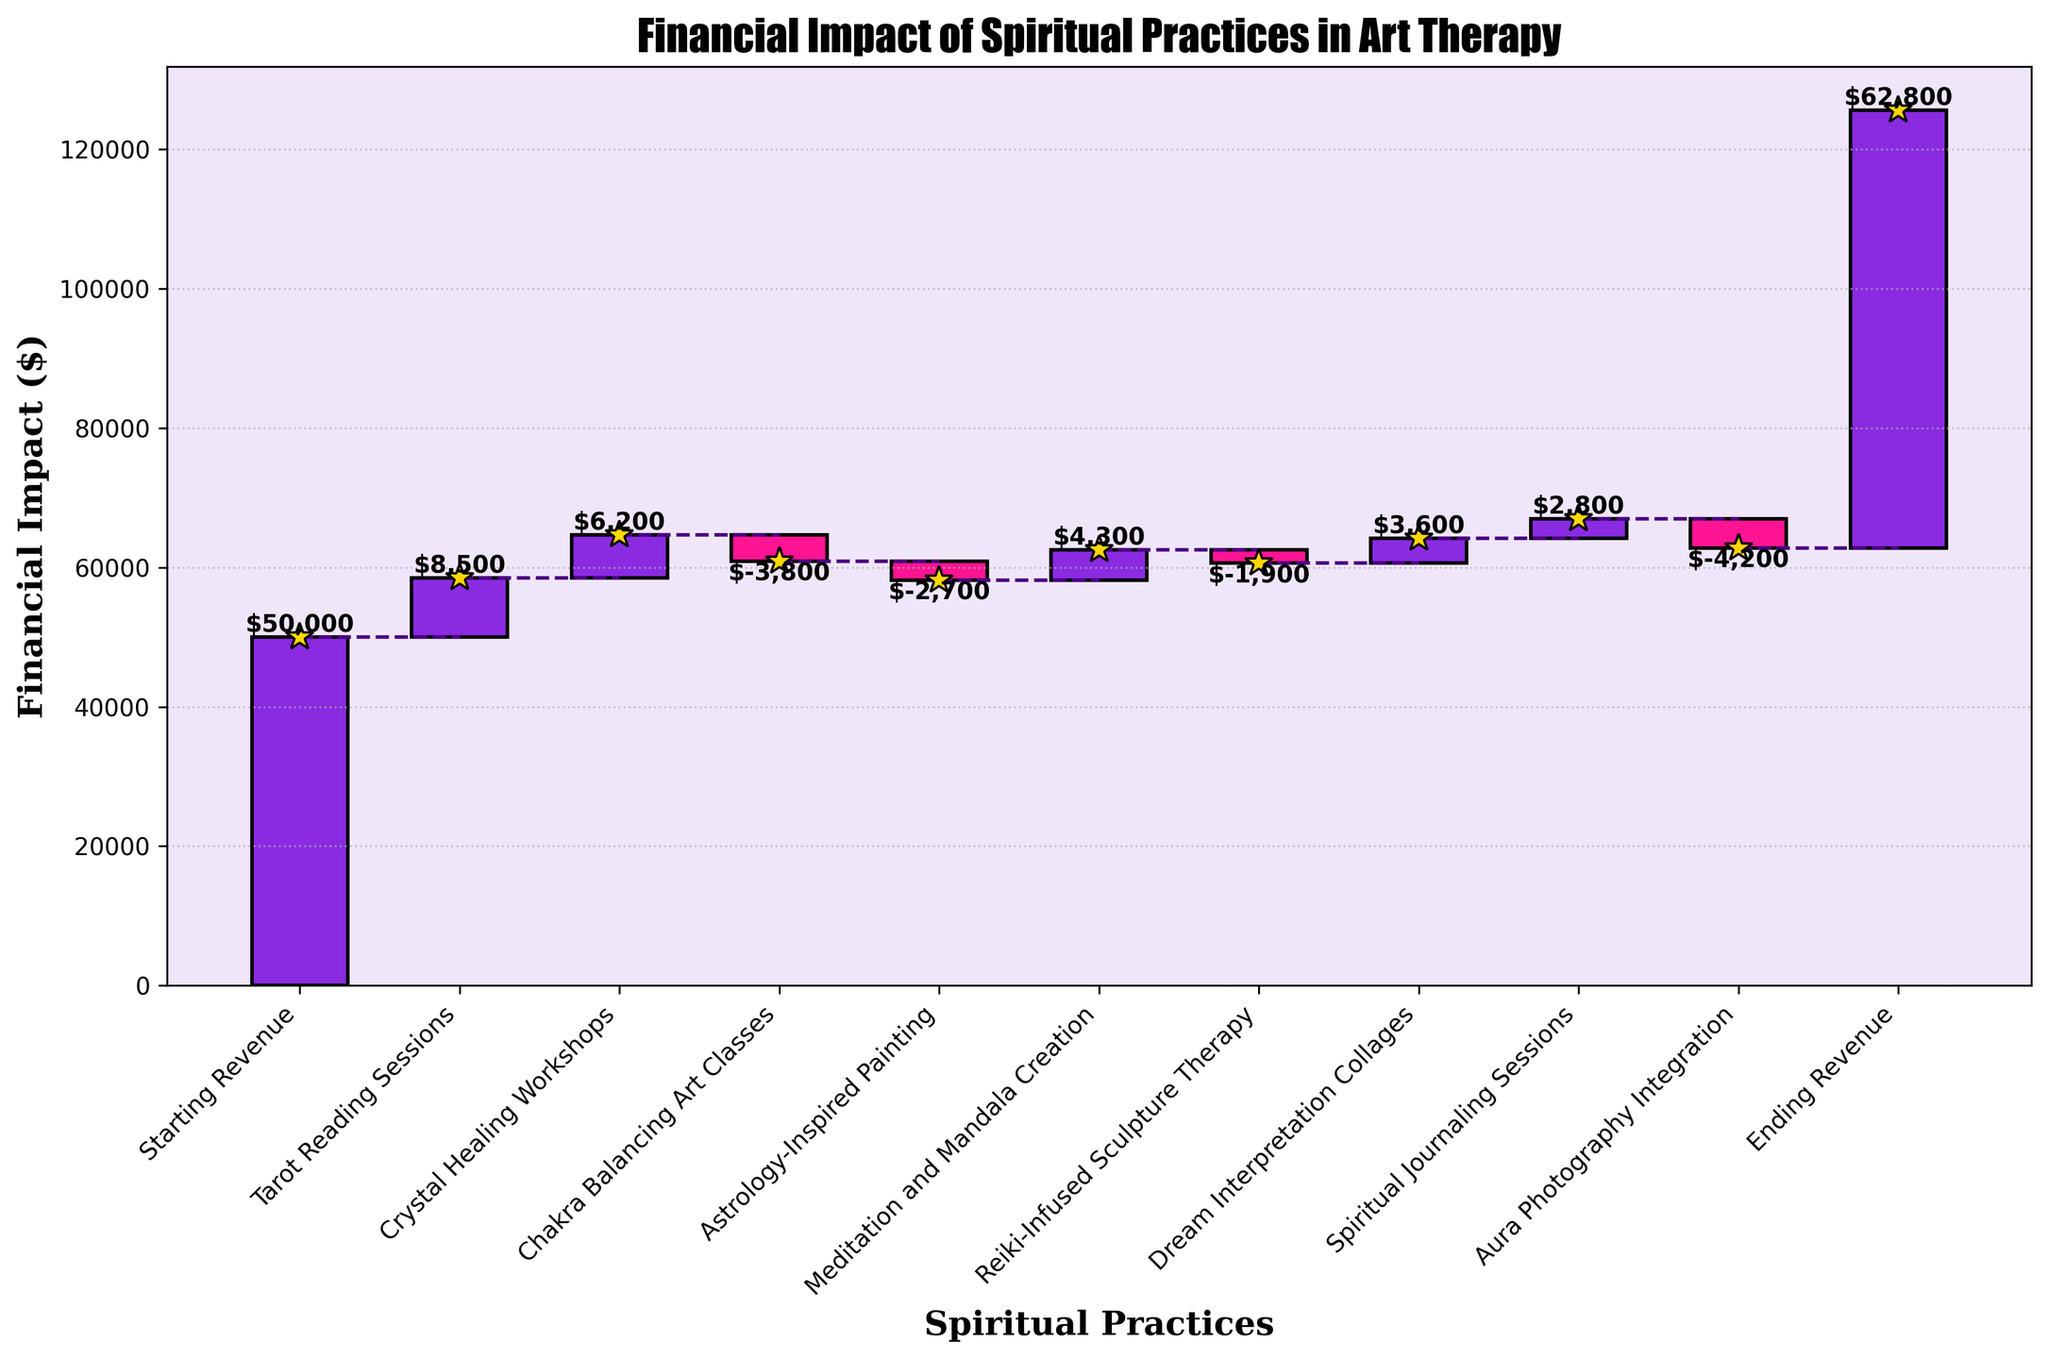What is the title of the figure? The title is given at the top of the waterfall chart, providing a summary of what the chart depicts.
Answer: Financial Impact of Spiritual Practices in Art Therapy Which spiritual practice contributed the most positively to the revenue? The bar with the highest positive value indicates the most significant positive contribution; in this case, it is the Tarot Reading Sessions.
Answer: Tarot Reading Sessions Which spiritual practice led to the most significant revenue decrease? The bar with the largest negative value indicates the greatest loss; here, it is the Aura Photography Integration.
Answer: Aura Photography Integration How many spiritual practices are included in the chart? Count the distinct categories from the starting revenue to the ending revenue, excluding these two.
Answer: 8 What's the cumulative impact on revenue from spiritual practices that had a negative contribution? Sum the values of all bars pointing downward: -3800 (Chakra Balancing Art Classes) + -2700 (Astrology-Inspired Painting) + -1900 (Reiki-Infused Sculpture Therapy) + -4200 (Aura Photography Integration) = -12600.
Answer: -12600 What is the total revenue increase from spiritual practices that had a positive impact? Sum the values of all bars pointing upward: 8500 (Tarot Reading Sessions) + 6200 (Crystal Healing Workshops) + 4300 (Meditation and Mandala Creation) + 3600 (Dream Interpretation Collages) + 2800 (Spiritual Journaling Sessions) = 25400.
Answer: 25400 How does the revenue change from the starting to the ending value? Subtract the starting revenue from the ending revenue: 62800 - 50000 = 12800.
Answer: 12800 Which spiritual practice had the smallest financial impact? Identify the bar with the smallest value in absolute terms; here, it is the Reiki-Infused Sculpture Therapy with -1900.
Answer: Reiki-Infused Sculpture Therapy What is the cumulative revenue after the Crystal Healing Workshops? Add the starting revenue to the revenue from Tarot Reading Sessions and Crystal Healing Workshops: 50000 + 8500 + 6200 = 64700.
Answer: 64700 Are there more positive or negative financial contributions from spiritual practices? Count the number of positive and negative bars. There are 5 positive (Tarot Reading Sessions, Crystal Healing Workshops, Meditation and Mandala Creation, Dream Interpretation Collages, Spiritual Journaling Sessions) and 4 negative contributions (Chakra Balancing Art Classes, Astrology-Inspired Painting, Reiki-Infused Sculpture Therapy, Aura Photography Integration).
Answer: Positive contributions 